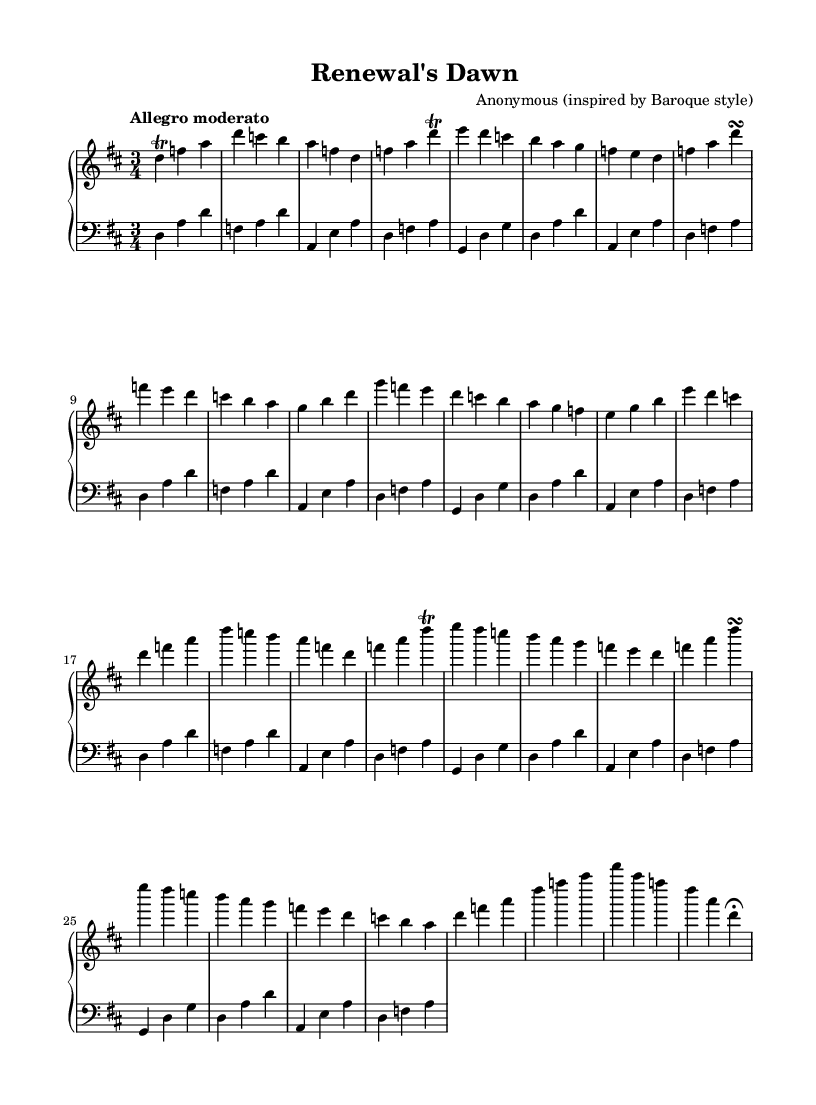What is the key signature of this music? The key signature is D major, which has two sharps: F sharp and C sharp. You can identify this by looking at the beginning of the staff where the sharps are indicated.
Answer: D major What is the time signature of this piece? The time signature is 3/4, which indicates that there are three beats in each measure and the quarter note gets one beat. This is displayed at the beginning of the music before the notes start.
Answer: 3/4 What is the tempo marking for this composition? The tempo marking is "Allegro moderato," which suggests a moderately fast pace. This information is typically found at the beginning of the composition, indicating how quickly the piece should be played.
Answer: Allegro moderato How many sections are there in this composition? There are three main sections: A, B, and A', along with a Coda section. You can determine this by observing the structure outlined in the sheet music where these sections are labeled.
Answer: Four What is a notable feature of the texture found in Baroque music like this piece? A notable feature is the use of counterpoint, where two or more independent melodies are combined. In this piece, the right hand typically plays melodic material while the left hand provides harmonic support, showcasing this characteristic.
Answer: Counterpoint What type of ornamentation is present in this piece? There is a trill ornamentation indicated, which involves rapidly alternating between two adjacent notes. You can see the trill symbol next to specific notes in the right hand part of the score.
Answer: Trill What is the overall mood conveyed by this piece? The overall mood is uplifting and celebratory, characterized by its bright key signature and lively tempo. These elements together foster a sense of joy and new beginnings, fitting for the theme indicated in the title.
Answer: Uplifting 